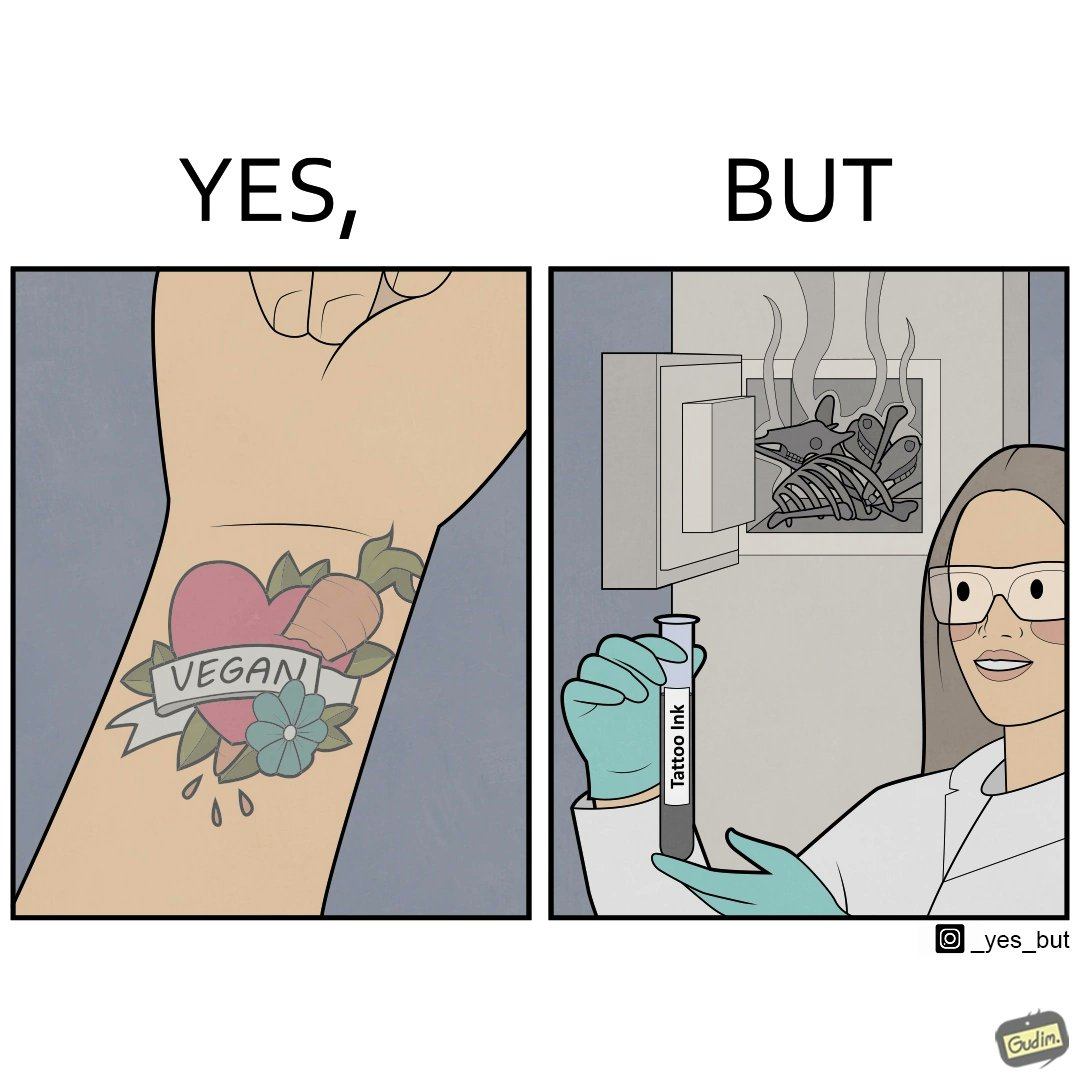Describe what you see in the left and right parts of this image. In the left part of the image: Image of a person's tattoo that says 'vegan' In the right part of the image: Image of a scientist making tattoo ink using animal bones. 